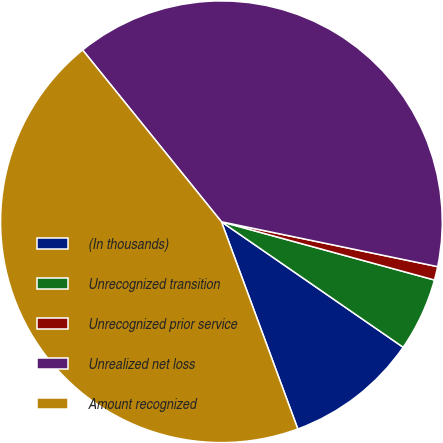<chart> <loc_0><loc_0><loc_500><loc_500><pie_chart><fcel>(In thousands)<fcel>Unrecognized transition<fcel>Unrecognized prior service<fcel>Unrealized net loss<fcel>Amount recognized<nl><fcel>9.76%<fcel>5.37%<fcel>0.99%<fcel>39.07%<fcel>44.8%<nl></chart> 